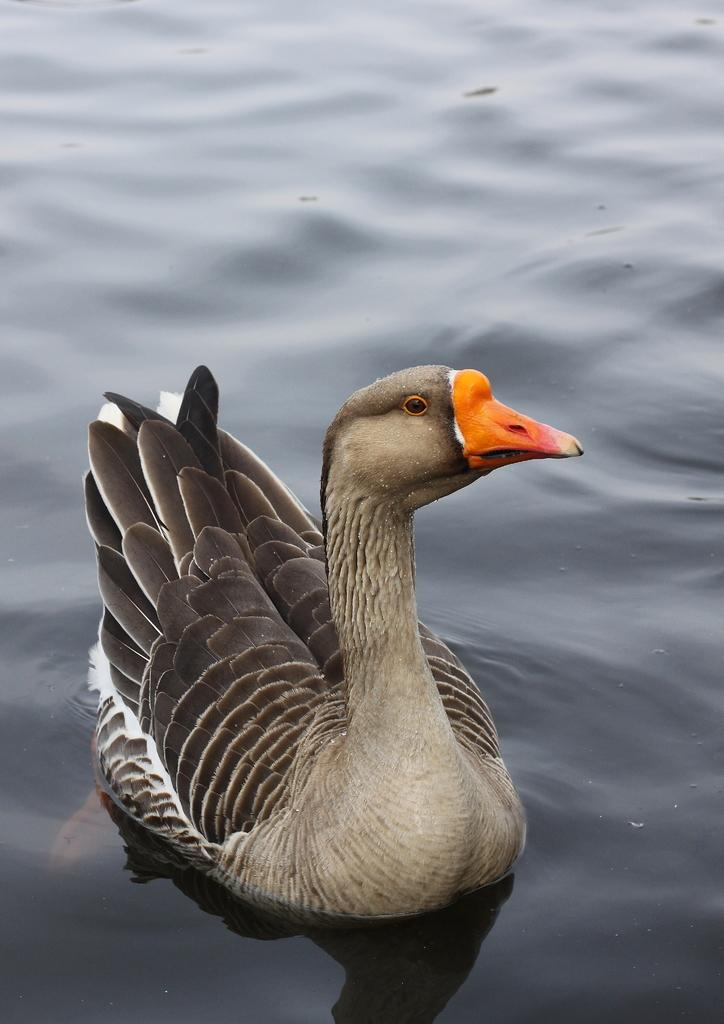What animal can be seen in the image? There is a duck in the image. What is the duck doing in the image? The duck is swimming in the river. What historical discovery was made by the duck in the image? There is no historical discovery mentioned in the image, and the duck is not depicted as making any discoveries. 